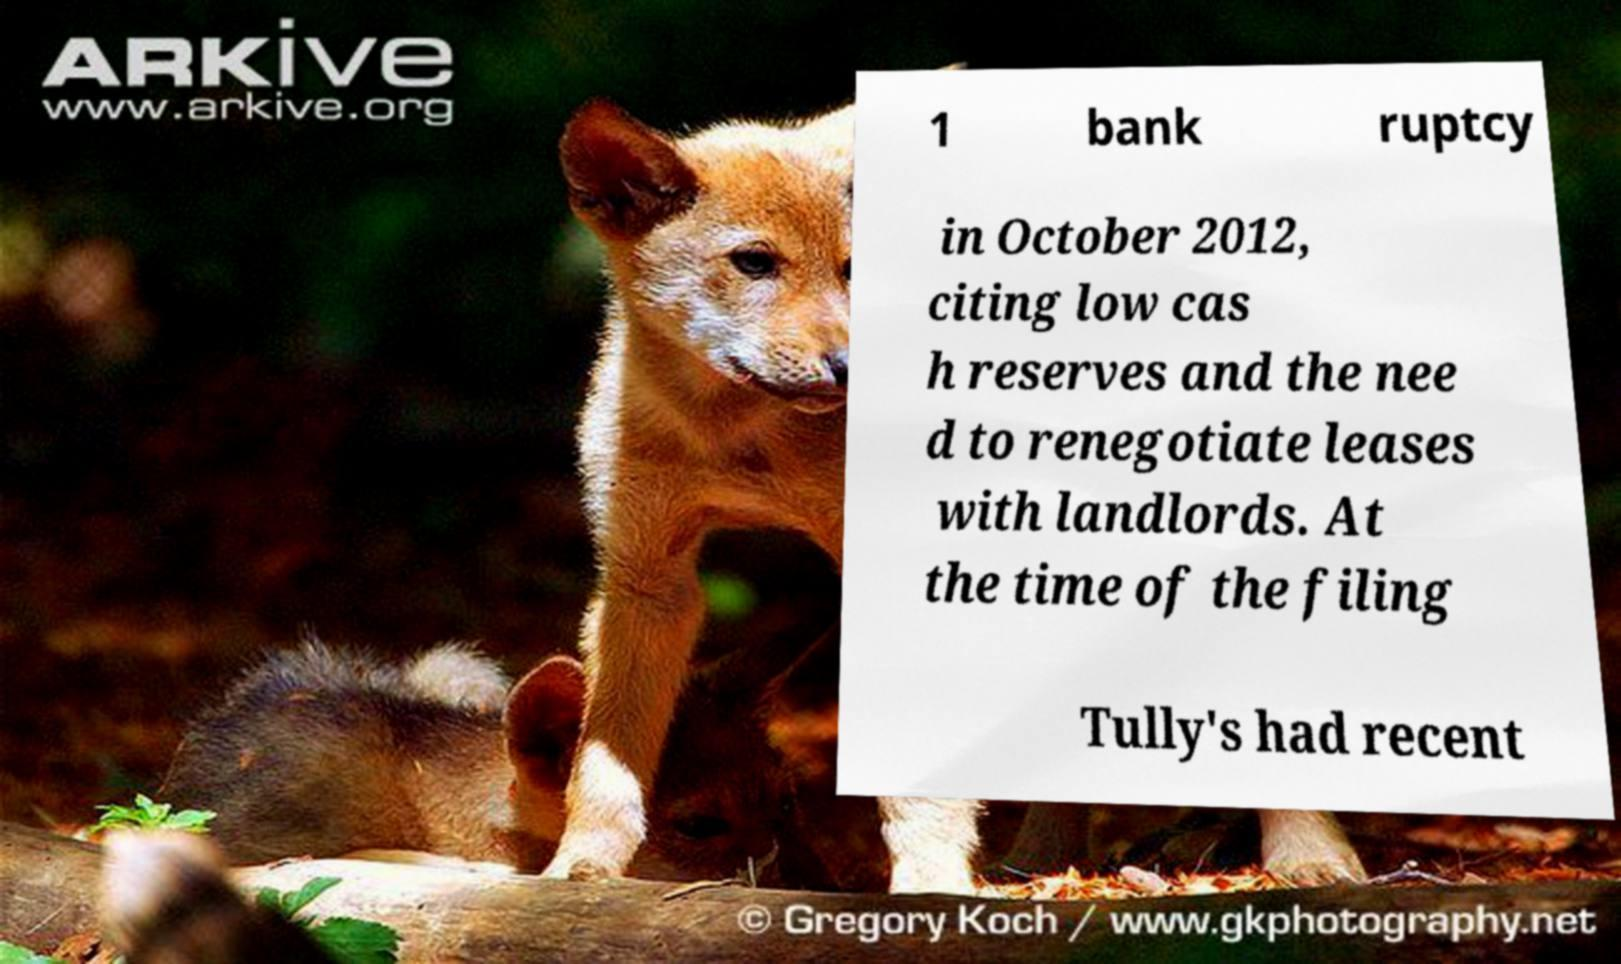There's text embedded in this image that I need extracted. Can you transcribe it verbatim? 1 bank ruptcy in October 2012, citing low cas h reserves and the nee d to renegotiate leases with landlords. At the time of the filing Tully's had recent 